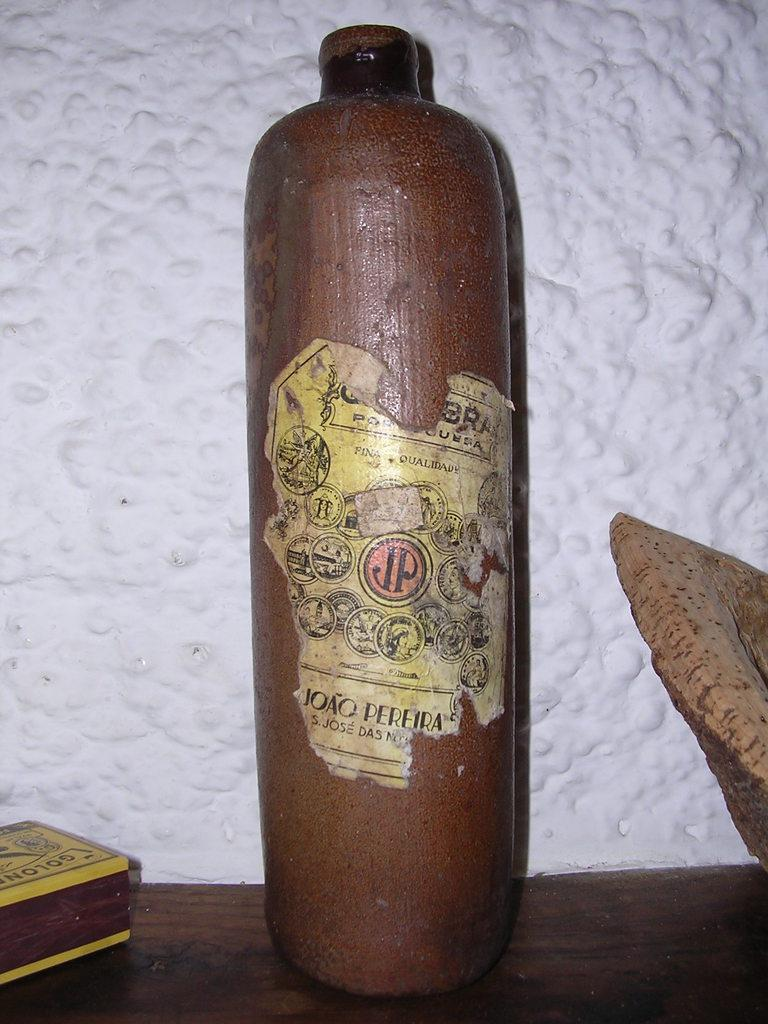What can be seen in the image that is typically used for holding liquids? There is a bottle in the image that is typically used for holding liquids. What type of surface can be seen in the image? There are things on a wooden surface in the image. What color is the wall visible in the background of the image? There is a white wall in the background of the image. What type of dress is the person wearing in the image? There is no person present in the image, so it is not possible to determine what type of dress they might be wearing. 